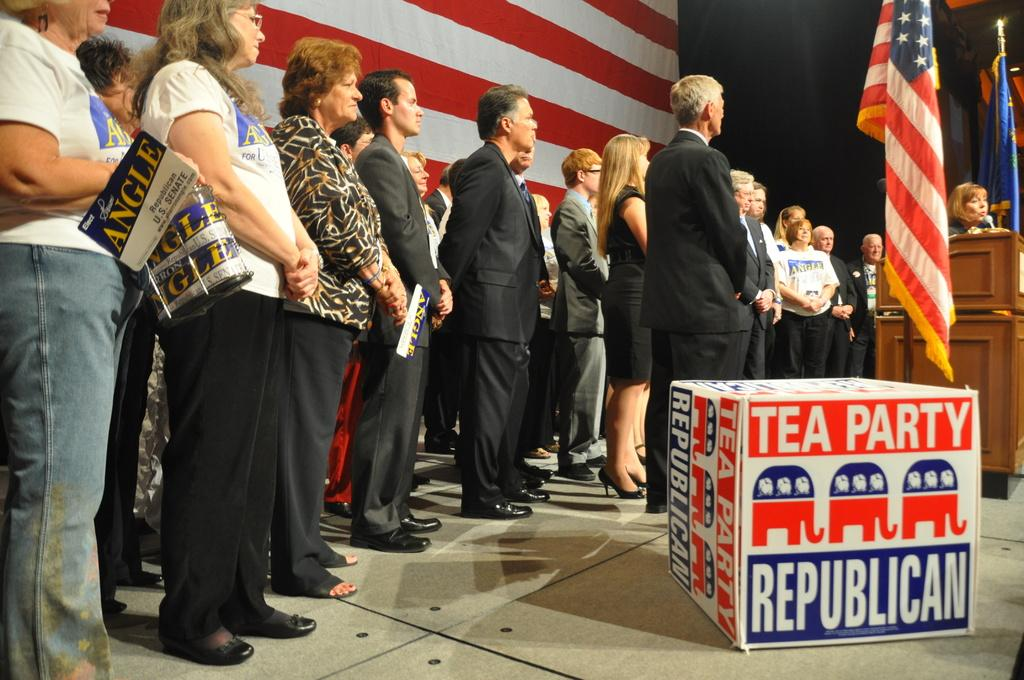What is happening in the middle of the image? There are people standing in the middle of the image. What can be seen in the image besides the people? There are flags present and a table in the image. What is visible in the background of the image? There is a banner visible in the background. Are there any cobwebs visible on the side of the table in the image? There is no mention of cobwebs in the provided facts, and therefore we cannot determine their presence in the image. 